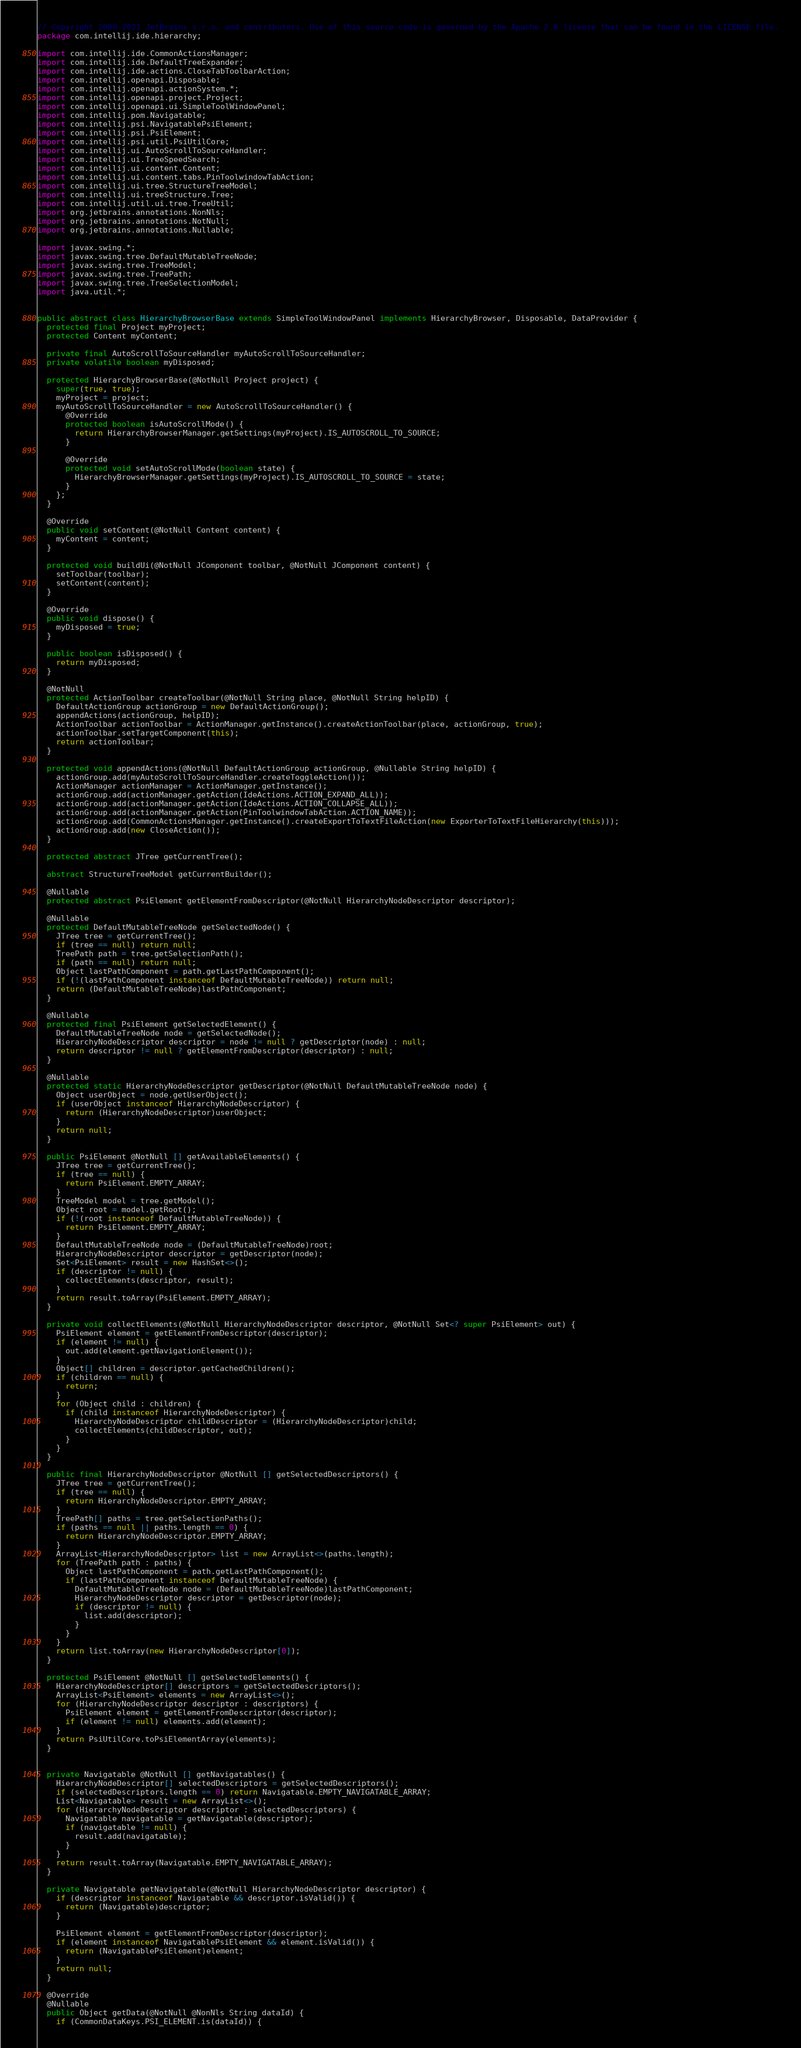<code> <loc_0><loc_0><loc_500><loc_500><_Java_>// Copyright 2000-2021 JetBrains s.r.o. and contributors. Use of this source code is governed by the Apache 2.0 license that can be found in the LICENSE file.
package com.intellij.ide.hierarchy;

import com.intellij.ide.CommonActionsManager;
import com.intellij.ide.DefaultTreeExpander;
import com.intellij.ide.actions.CloseTabToolbarAction;
import com.intellij.openapi.Disposable;
import com.intellij.openapi.actionSystem.*;
import com.intellij.openapi.project.Project;
import com.intellij.openapi.ui.SimpleToolWindowPanel;
import com.intellij.pom.Navigatable;
import com.intellij.psi.NavigatablePsiElement;
import com.intellij.psi.PsiElement;
import com.intellij.psi.util.PsiUtilCore;
import com.intellij.ui.AutoScrollToSourceHandler;
import com.intellij.ui.TreeSpeedSearch;
import com.intellij.ui.content.Content;
import com.intellij.ui.content.tabs.PinToolwindowTabAction;
import com.intellij.ui.tree.StructureTreeModel;
import com.intellij.ui.treeStructure.Tree;
import com.intellij.util.ui.tree.TreeUtil;
import org.jetbrains.annotations.NonNls;
import org.jetbrains.annotations.NotNull;
import org.jetbrains.annotations.Nullable;

import javax.swing.*;
import javax.swing.tree.DefaultMutableTreeNode;
import javax.swing.tree.TreeModel;
import javax.swing.tree.TreePath;
import javax.swing.tree.TreeSelectionModel;
import java.util.*;


public abstract class HierarchyBrowserBase extends SimpleToolWindowPanel implements HierarchyBrowser, Disposable, DataProvider {
  protected final Project myProject;
  protected Content myContent;

  private final AutoScrollToSourceHandler myAutoScrollToSourceHandler;
  private volatile boolean myDisposed;

  protected HierarchyBrowserBase(@NotNull Project project) {
    super(true, true);
    myProject = project;
    myAutoScrollToSourceHandler = new AutoScrollToSourceHandler() {
      @Override
      protected boolean isAutoScrollMode() {
        return HierarchyBrowserManager.getSettings(myProject).IS_AUTOSCROLL_TO_SOURCE;
      }

      @Override
      protected void setAutoScrollMode(boolean state) {
        HierarchyBrowserManager.getSettings(myProject).IS_AUTOSCROLL_TO_SOURCE = state;
      }
    };
  }

  @Override
  public void setContent(@NotNull Content content) {
    myContent = content;
  }

  protected void buildUi(@NotNull JComponent toolbar, @NotNull JComponent content) {
    setToolbar(toolbar);
    setContent(content);
  }

  @Override
  public void dispose() {
    myDisposed = true;
  }

  public boolean isDisposed() {
    return myDisposed;
  }

  @NotNull
  protected ActionToolbar createToolbar(@NotNull String place, @NotNull String helpID) {
    DefaultActionGroup actionGroup = new DefaultActionGroup();
    appendActions(actionGroup, helpID);
    ActionToolbar actionToolbar = ActionManager.getInstance().createActionToolbar(place, actionGroup, true);
    actionToolbar.setTargetComponent(this);
    return actionToolbar;
  }

  protected void appendActions(@NotNull DefaultActionGroup actionGroup, @Nullable String helpID) {
    actionGroup.add(myAutoScrollToSourceHandler.createToggleAction());
    ActionManager actionManager = ActionManager.getInstance();
    actionGroup.add(actionManager.getAction(IdeActions.ACTION_EXPAND_ALL));
    actionGroup.add(actionManager.getAction(IdeActions.ACTION_COLLAPSE_ALL));
    actionGroup.add(actionManager.getAction(PinToolwindowTabAction.ACTION_NAME));
    actionGroup.add(CommonActionsManager.getInstance().createExportToTextFileAction(new ExporterToTextFileHierarchy(this)));
    actionGroup.add(new CloseAction());
  }

  protected abstract JTree getCurrentTree();

  abstract StructureTreeModel getCurrentBuilder();

  @Nullable
  protected abstract PsiElement getElementFromDescriptor(@NotNull HierarchyNodeDescriptor descriptor);

  @Nullable
  protected DefaultMutableTreeNode getSelectedNode() {
    JTree tree = getCurrentTree();
    if (tree == null) return null;
    TreePath path = tree.getSelectionPath();
    if (path == null) return null;
    Object lastPathComponent = path.getLastPathComponent();
    if (!(lastPathComponent instanceof DefaultMutableTreeNode)) return null;
    return (DefaultMutableTreeNode)lastPathComponent;
  }

  @Nullable
  protected final PsiElement getSelectedElement() {
    DefaultMutableTreeNode node = getSelectedNode();
    HierarchyNodeDescriptor descriptor = node != null ? getDescriptor(node) : null;
    return descriptor != null ? getElementFromDescriptor(descriptor) : null;
  }

  @Nullable
  protected static HierarchyNodeDescriptor getDescriptor(@NotNull DefaultMutableTreeNode node) {
    Object userObject = node.getUserObject();
    if (userObject instanceof HierarchyNodeDescriptor) {
      return (HierarchyNodeDescriptor)userObject;
    }
    return null;
  }

  public PsiElement @NotNull [] getAvailableElements() {
    JTree tree = getCurrentTree();
    if (tree == null) {
      return PsiElement.EMPTY_ARRAY;
    }
    TreeModel model = tree.getModel();
    Object root = model.getRoot();
    if (!(root instanceof DefaultMutableTreeNode)) {
      return PsiElement.EMPTY_ARRAY;
    }
    DefaultMutableTreeNode node = (DefaultMutableTreeNode)root;
    HierarchyNodeDescriptor descriptor = getDescriptor(node);
    Set<PsiElement> result = new HashSet<>();
    if (descriptor != null) {
      collectElements(descriptor, result);
    }
    return result.toArray(PsiElement.EMPTY_ARRAY);
  }

  private void collectElements(@NotNull HierarchyNodeDescriptor descriptor, @NotNull Set<? super PsiElement> out) {
    PsiElement element = getElementFromDescriptor(descriptor);
    if (element != null) {
      out.add(element.getNavigationElement());
    }
    Object[] children = descriptor.getCachedChildren();
    if (children == null) {
      return;
    }
    for (Object child : children) {
      if (child instanceof HierarchyNodeDescriptor) {
        HierarchyNodeDescriptor childDescriptor = (HierarchyNodeDescriptor)child;
        collectElements(childDescriptor, out);
      }
    }
  }

  public final HierarchyNodeDescriptor @NotNull [] getSelectedDescriptors() {
    JTree tree = getCurrentTree();
    if (tree == null) {
      return HierarchyNodeDescriptor.EMPTY_ARRAY;
    }
    TreePath[] paths = tree.getSelectionPaths();
    if (paths == null || paths.length == 0) {
      return HierarchyNodeDescriptor.EMPTY_ARRAY;
    }
    ArrayList<HierarchyNodeDescriptor> list = new ArrayList<>(paths.length);
    for (TreePath path : paths) {
      Object lastPathComponent = path.getLastPathComponent();
      if (lastPathComponent instanceof DefaultMutableTreeNode) {
        DefaultMutableTreeNode node = (DefaultMutableTreeNode)lastPathComponent;
        HierarchyNodeDescriptor descriptor = getDescriptor(node);
        if (descriptor != null) {
          list.add(descriptor);
        }
      }
    }
    return list.toArray(new HierarchyNodeDescriptor[0]);
  }

  protected PsiElement @NotNull [] getSelectedElements() {
    HierarchyNodeDescriptor[] descriptors = getSelectedDescriptors();
    ArrayList<PsiElement> elements = new ArrayList<>();
    for (HierarchyNodeDescriptor descriptor : descriptors) {
      PsiElement element = getElementFromDescriptor(descriptor);
      if (element != null) elements.add(element);
    }
    return PsiUtilCore.toPsiElementArray(elements);
  }


  private Navigatable @NotNull [] getNavigatables() {
    HierarchyNodeDescriptor[] selectedDescriptors = getSelectedDescriptors();
    if (selectedDescriptors.length == 0) return Navigatable.EMPTY_NAVIGATABLE_ARRAY;
    List<Navigatable> result = new ArrayList<>();
    for (HierarchyNodeDescriptor descriptor : selectedDescriptors) {
      Navigatable navigatable = getNavigatable(descriptor);
      if (navigatable != null) {
        result.add(navigatable);
      }
    }
    return result.toArray(Navigatable.EMPTY_NAVIGATABLE_ARRAY);
  }

  private Navigatable getNavigatable(@NotNull HierarchyNodeDescriptor descriptor) {
    if (descriptor instanceof Navigatable && descriptor.isValid()) {
      return (Navigatable)descriptor;
    }

    PsiElement element = getElementFromDescriptor(descriptor);
    if (element instanceof NavigatablePsiElement && element.isValid()) {
      return (NavigatablePsiElement)element;
    }
    return null;
  }

  @Override
  @Nullable
  public Object getData(@NotNull @NonNls String dataId) {
    if (CommonDataKeys.PSI_ELEMENT.is(dataId)) {</code> 